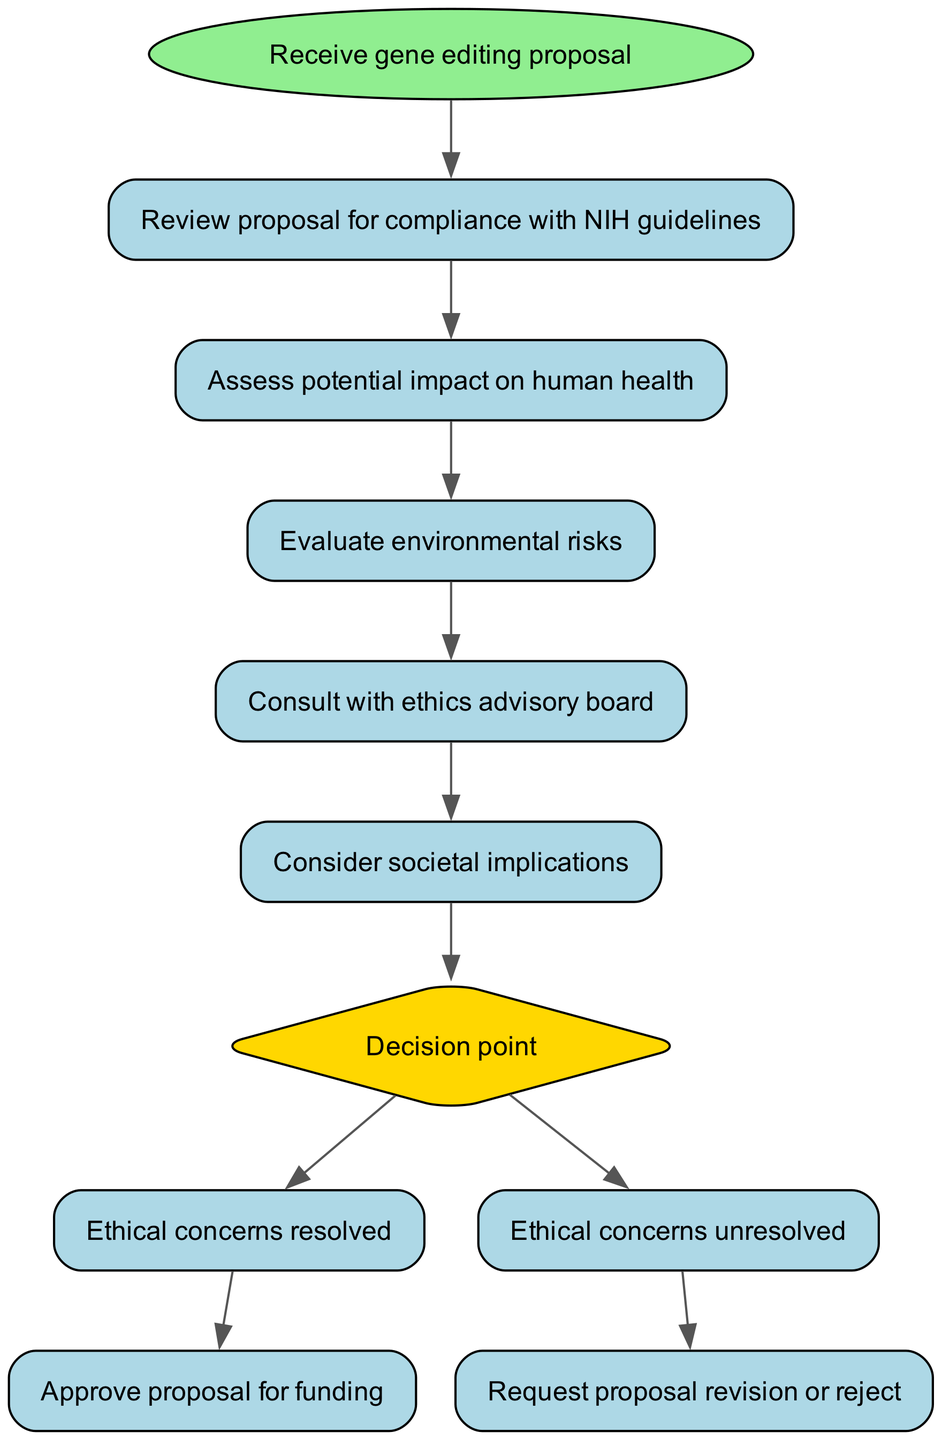What is the first step in the protocol? The first step in the protocol is to receive the gene editing proposal, which is the starting point of the flow chart.
Answer: Receive gene editing proposal How many steps are there before the decision point? There are five steps that precede the decision point in the flow chart, listed sequentially from reviewing the proposal to consulting with the ethics advisory board.
Answer: 5 What is the last action taken if ethical concerns are resolved? If ethical concerns are resolved, the last action is to approve the proposal for funding, which leads to the final step as indicated in the flowchart.
Answer: Approve proposal for funding What does the decision point evaluate? The decision point evaluates the resolution of ethical concerns, determining whether they have been resolved or remain unresolved.
Answer: Ethical concerns What step occurs after assessing potential impact on human health? After assessing the potential impact on human health, the next step is to evaluate environmental risks, following the specified order of the protocol.
Answer: Evaluate environmental risks What two options are available at the decision point? The two options available at the decision point are "Ethical concerns resolved" and "Ethical concerns unresolved," each leading to a different outcome in the flowchart.
Answer: Ethical concerns resolved, Ethical concerns unresolved How many nodes represent the actual steps in the process, excluding the start and decision nodes? There are six nodes representing actual steps in the process when excluding both the start node and the decision node; these represent the individual actions taken.
Answer: 6 What happens if ethical concerns are unresolved? If ethical concerns are unresolved, the protocol instructs to request a proposal revision or to reject it, indicating the pathway when concerns persist.
Answer: Request proposal revision or reject 